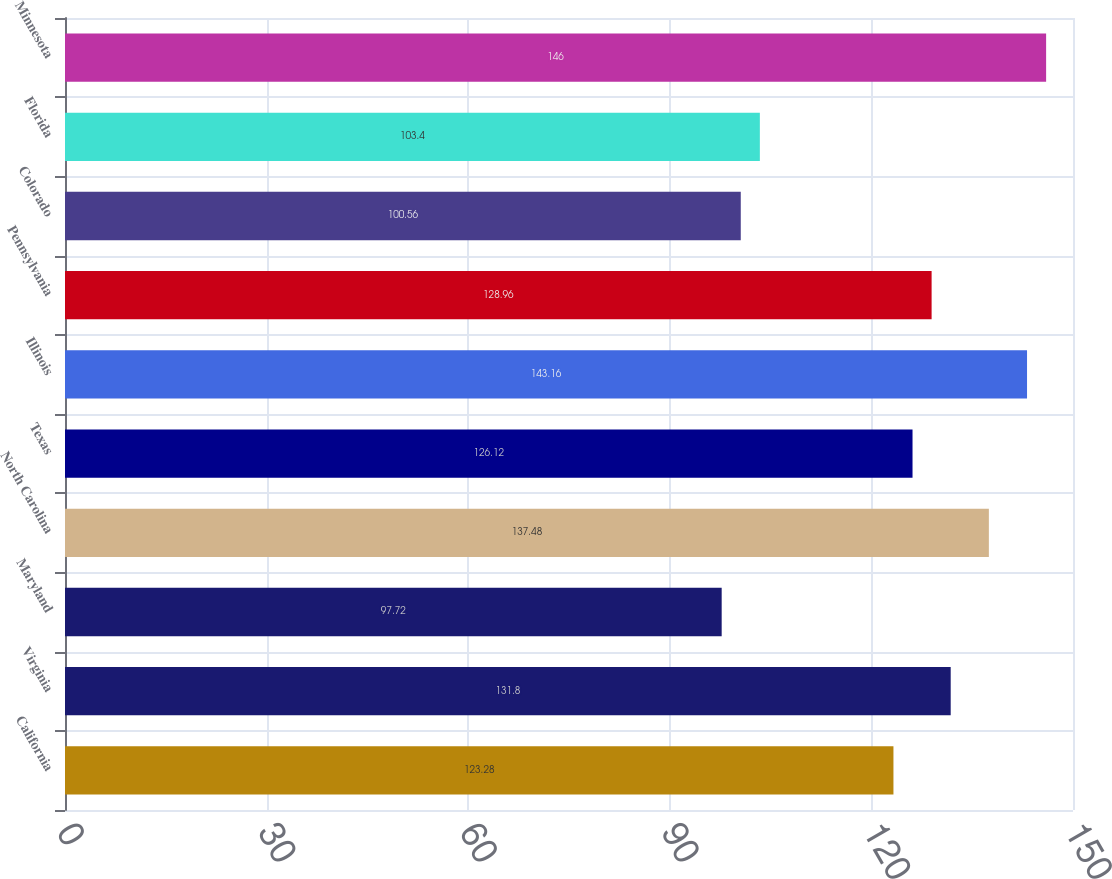Convert chart to OTSL. <chart><loc_0><loc_0><loc_500><loc_500><bar_chart><fcel>California<fcel>Virginia<fcel>Maryland<fcel>North Carolina<fcel>Texas<fcel>Illinois<fcel>Pennsylvania<fcel>Colorado<fcel>Florida<fcel>Minnesota<nl><fcel>123.28<fcel>131.8<fcel>97.72<fcel>137.48<fcel>126.12<fcel>143.16<fcel>128.96<fcel>100.56<fcel>103.4<fcel>146<nl></chart> 